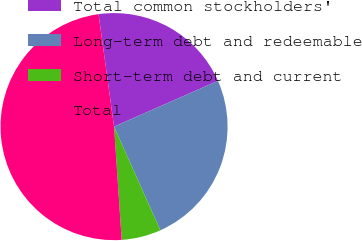Convert chart. <chart><loc_0><loc_0><loc_500><loc_500><pie_chart><fcel>Total common stockholders'<fcel>Long-term debt and redeemable<fcel>Short-term debt and current<fcel>Total<nl><fcel>20.58%<fcel>24.91%<fcel>5.62%<fcel>48.89%<nl></chart> 